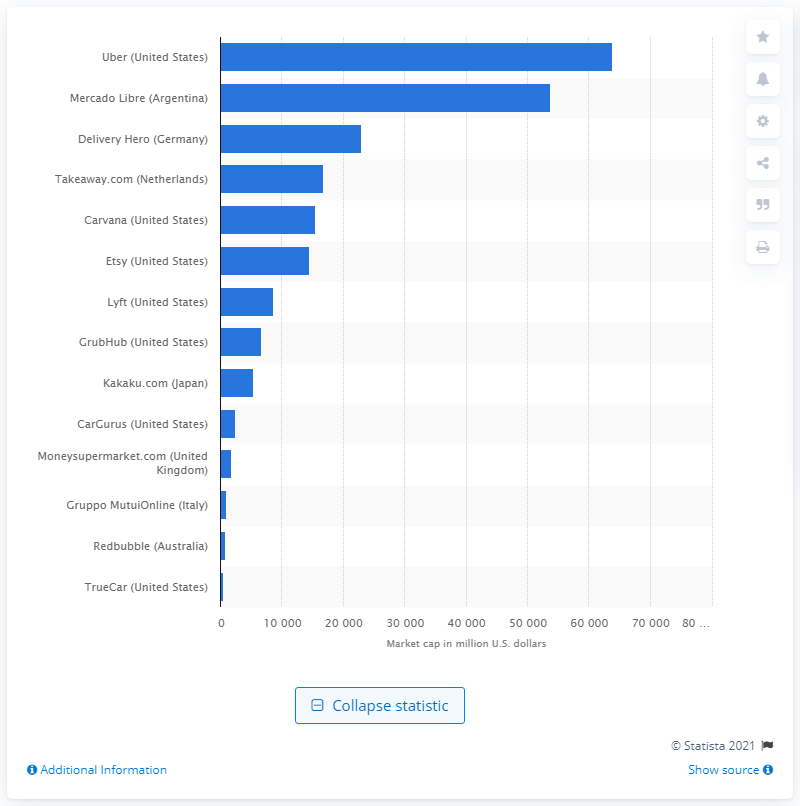Indicate a few pertinent items in this graphic. As of [date], Uber's market capitalization was approximately 63,936 dollars. Mercado Libre's market capitalization is 53,810. 